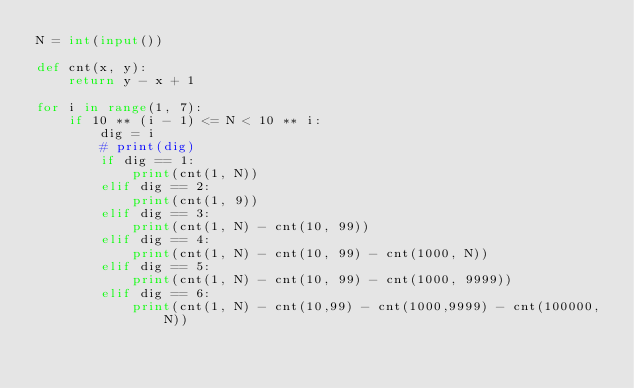Convert code to text. <code><loc_0><loc_0><loc_500><loc_500><_Python_>N = int(input())

def cnt(x, y):
    return y - x + 1

for i in range(1, 7):
    if 10 ** (i - 1) <= N < 10 ** i:
        dig = i
        # print(dig)
        if dig == 1:
            print(cnt(1, N))
        elif dig == 2:
            print(cnt(1, 9))
        elif dig == 3:
            print(cnt(1, N) - cnt(10, 99))
        elif dig == 4:
            print(cnt(1, N) - cnt(10, 99) - cnt(1000, N))
        elif dig == 5:
            print(cnt(1, N) - cnt(10, 99) - cnt(1000, 9999))
        elif dig == 6:
            print(cnt(1, N) - cnt(10,99) - cnt(1000,9999) - cnt(100000, N))
</code> 